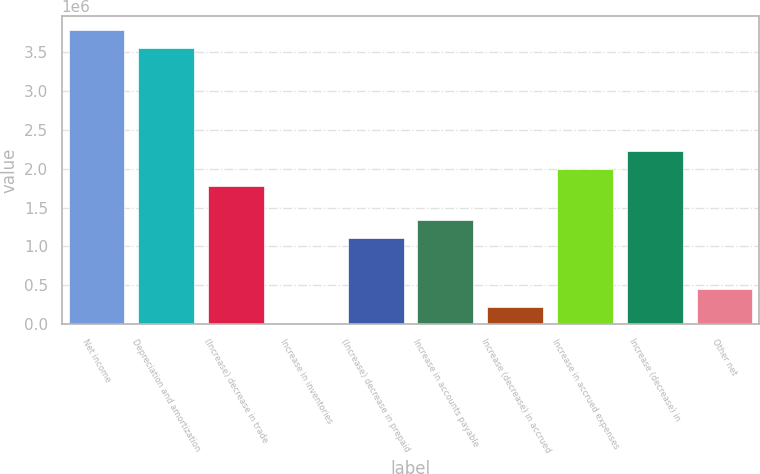<chart> <loc_0><loc_0><loc_500><loc_500><bar_chart><fcel>Net income<fcel>Depreciation and amortization<fcel>(Increase) decrease in trade<fcel>Increase in inventories<fcel>(Increase) decrease in prepaid<fcel>Increase in accounts payable<fcel>Increase (decrease) in accrued<fcel>Increase in accrued expenses<fcel>Increase (decrease) in<fcel>Other net<nl><fcel>3.77991e+06<fcel>3.55757e+06<fcel>1.77886e+06<fcel>140<fcel>1.11184e+06<fcel>1.33418e+06<fcel>222479<fcel>2.00119e+06<fcel>2.22353e+06<fcel>444819<nl></chart> 